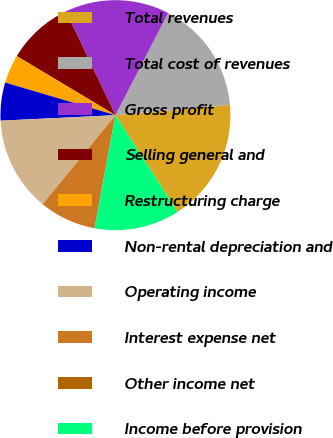<chart> <loc_0><loc_0><loc_500><loc_500><pie_chart><fcel>Total revenues<fcel>Total cost of revenues<fcel>Gross profit<fcel>Selling general and<fcel>Restructuring charge<fcel>Non-rental depreciation and<fcel>Operating income<fcel>Interest expense net<fcel>Other income net<fcel>Income before provision<nl><fcel>17.33%<fcel>15.99%<fcel>14.66%<fcel>9.33%<fcel>4.01%<fcel>5.34%<fcel>13.33%<fcel>8.0%<fcel>0.01%<fcel>12.0%<nl></chart> 